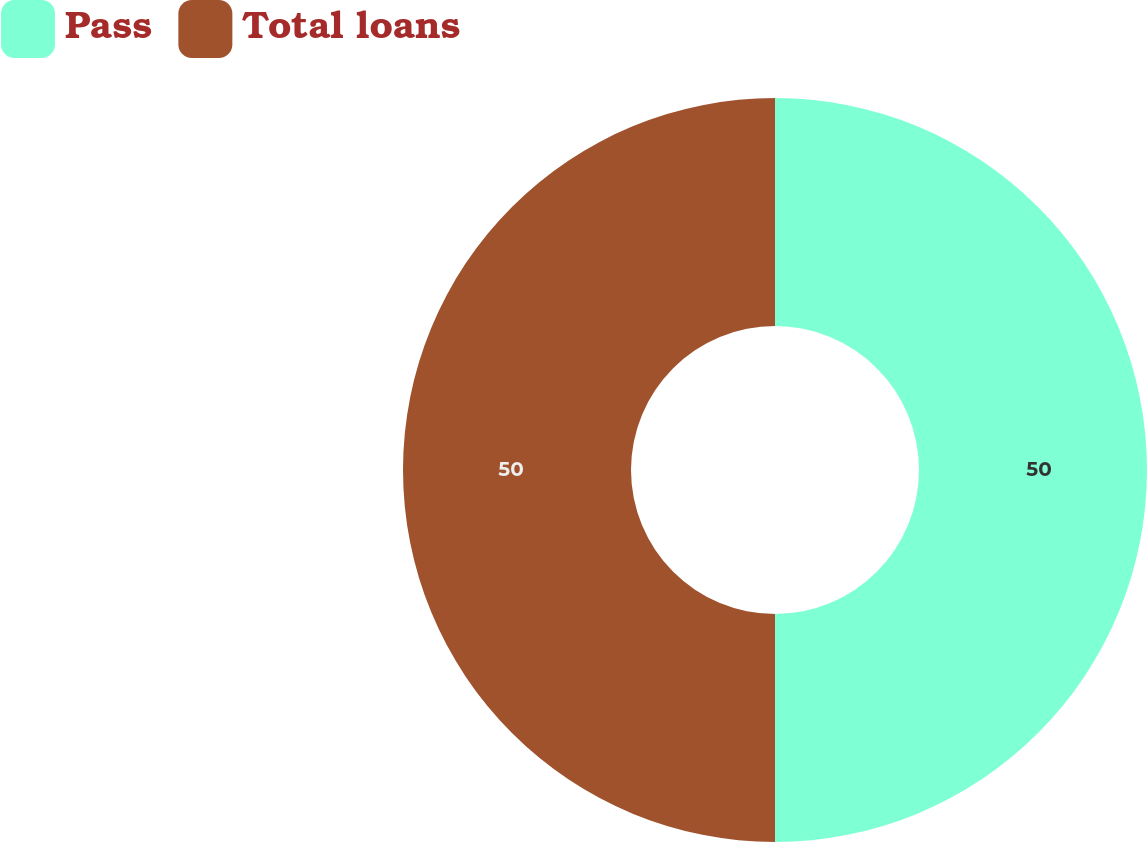Convert chart to OTSL. <chart><loc_0><loc_0><loc_500><loc_500><pie_chart><fcel>Pass<fcel>Total loans<nl><fcel>50.0%<fcel>50.0%<nl></chart> 